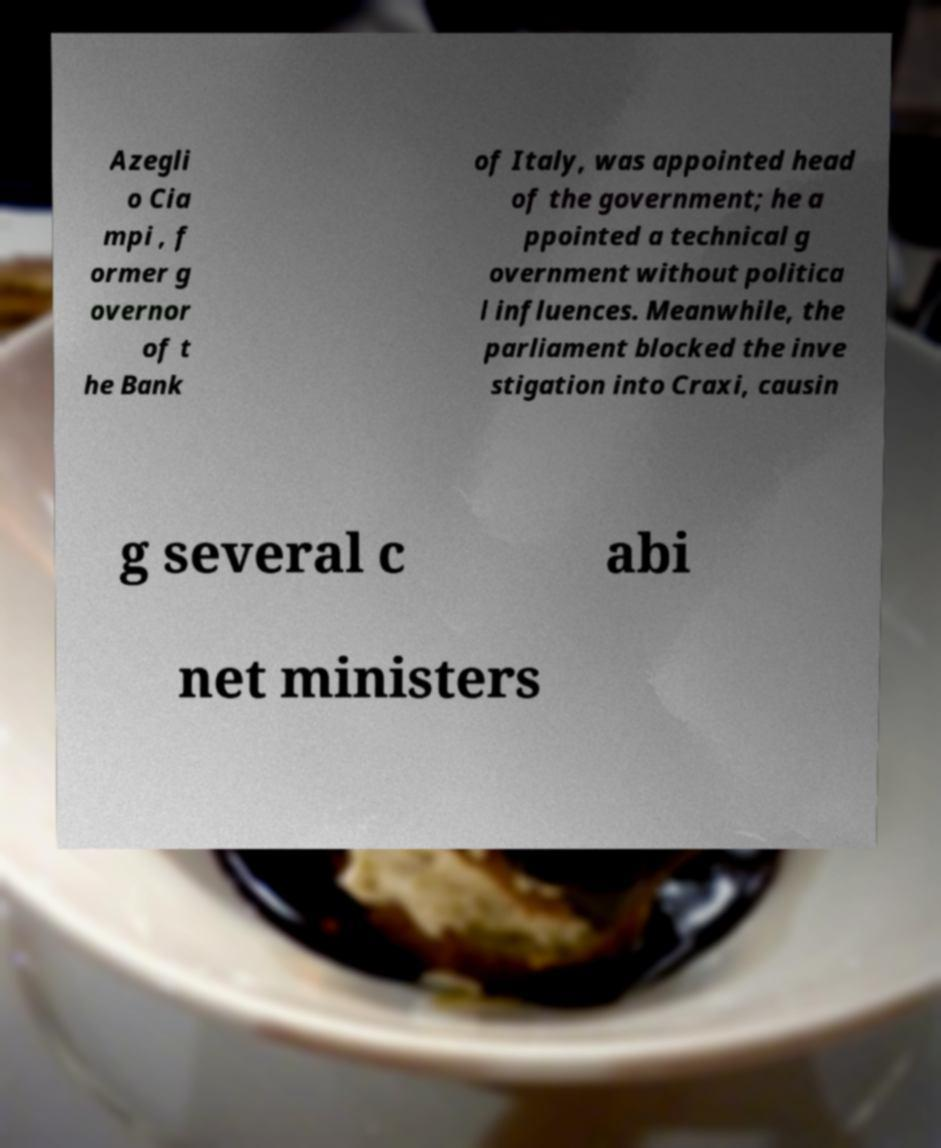Can you read and provide the text displayed in the image?This photo seems to have some interesting text. Can you extract and type it out for me? Azegli o Cia mpi , f ormer g overnor of t he Bank of Italy, was appointed head of the government; he a ppointed a technical g overnment without politica l influences. Meanwhile, the parliament blocked the inve stigation into Craxi, causin g several c abi net ministers 